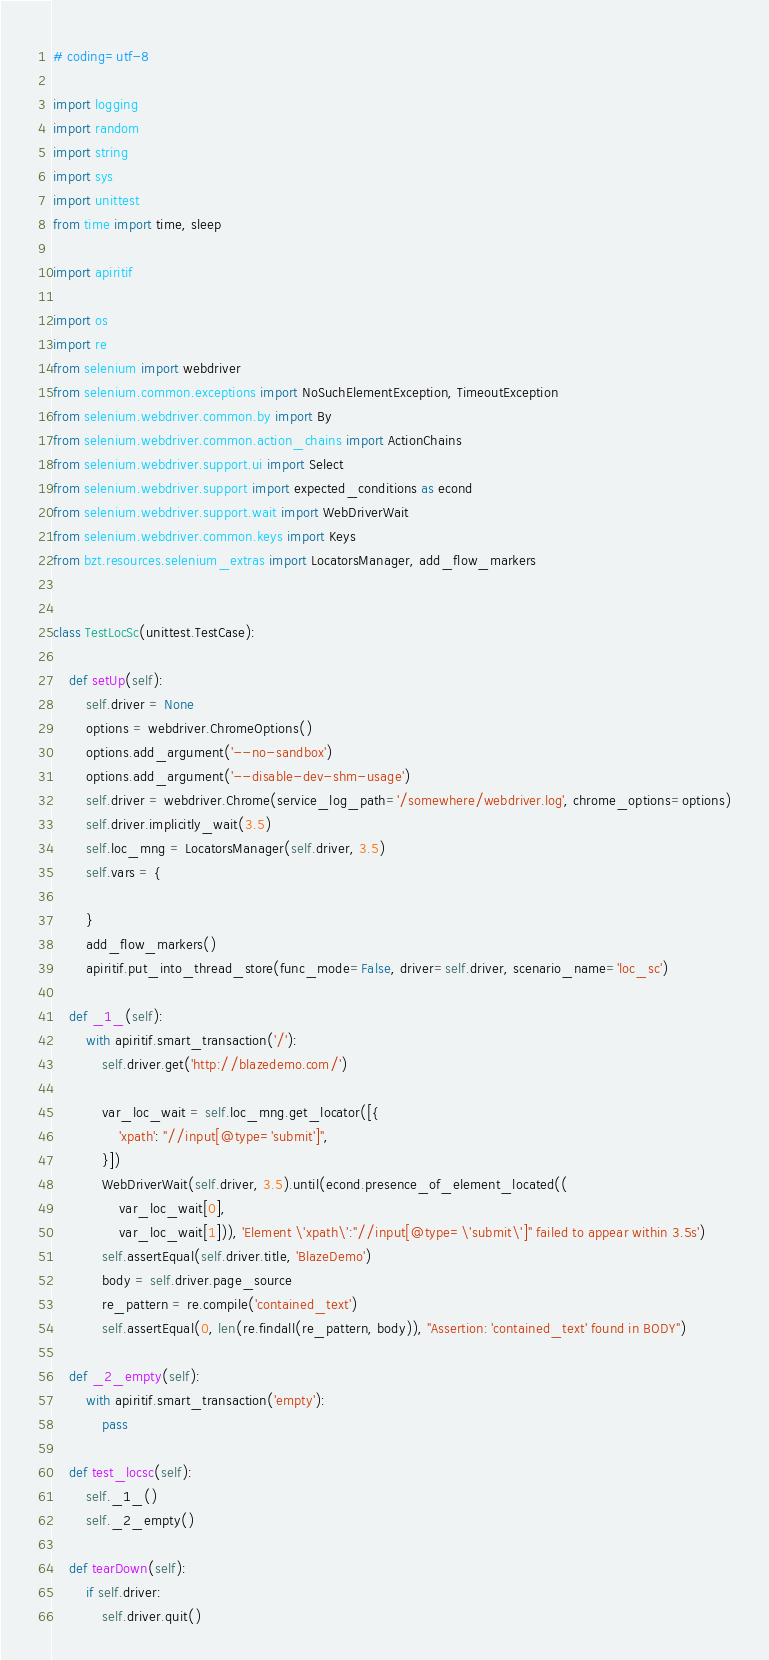<code> <loc_0><loc_0><loc_500><loc_500><_Python_># coding=utf-8

import logging
import random
import string
import sys
import unittest
from time import time, sleep

import apiritif

import os
import re
from selenium import webdriver
from selenium.common.exceptions import NoSuchElementException, TimeoutException
from selenium.webdriver.common.by import By
from selenium.webdriver.common.action_chains import ActionChains
from selenium.webdriver.support.ui import Select
from selenium.webdriver.support import expected_conditions as econd
from selenium.webdriver.support.wait import WebDriverWait
from selenium.webdriver.common.keys import Keys
from bzt.resources.selenium_extras import LocatorsManager, add_flow_markers


class TestLocSc(unittest.TestCase):

    def setUp(self):
        self.driver = None
        options = webdriver.ChromeOptions()
        options.add_argument('--no-sandbox')
        options.add_argument('--disable-dev-shm-usage')
        self.driver = webdriver.Chrome(service_log_path='/somewhere/webdriver.log', chrome_options=options)
        self.driver.implicitly_wait(3.5)
        self.loc_mng = LocatorsManager(self.driver, 3.5)
        self.vars = {

        }
        add_flow_markers()
        apiritif.put_into_thread_store(func_mode=False, driver=self.driver, scenario_name='loc_sc')

    def _1_(self):
        with apiritif.smart_transaction('/'):
            self.driver.get('http://blazedemo.com/')

            var_loc_wait = self.loc_mng.get_locator([{
                'xpath': "//input[@type='submit']",
            }])
            WebDriverWait(self.driver, 3.5).until(econd.presence_of_element_located((
                var_loc_wait[0],
                var_loc_wait[1])), 'Element \'xpath\':"//input[@type=\'submit\']" failed to appear within 3.5s')
            self.assertEqual(self.driver.title, 'BlazeDemo')
            body = self.driver.page_source
            re_pattern = re.compile('contained_text')
            self.assertEqual(0, len(re.findall(re_pattern, body)), "Assertion: 'contained_text' found in BODY")

    def _2_empty(self):
        with apiritif.smart_transaction('empty'):
            pass

    def test_locsc(self):
        self._1_()
        self._2_empty()

    def tearDown(self):
        if self.driver:
            self.driver.quit()
</code> 